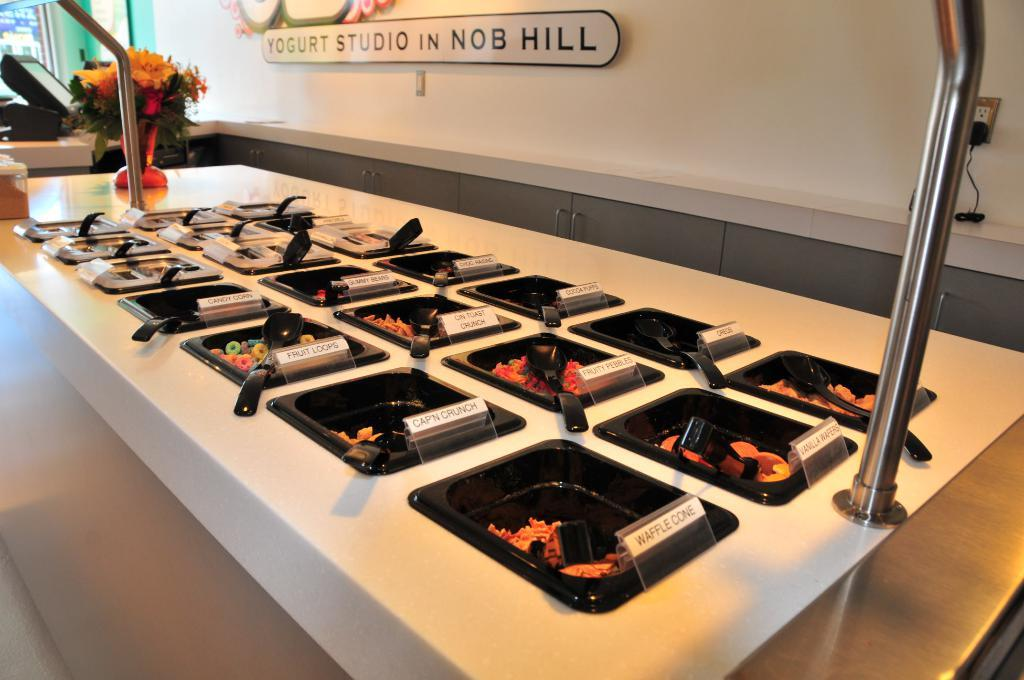<image>
Present a compact description of the photo's key features. ice cream flavor bins at yogurt studio in nob hill 